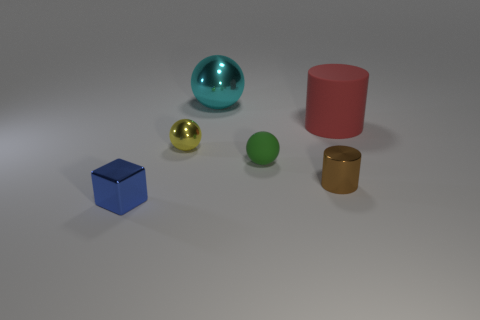There is a tiny brown cylinder; what number of rubber objects are to the right of it? To the right of the tiny brown cylinder, there appears to be just one rubber object. It's a green sphere that's positioned between the brown cylinder and the red cylinder. 